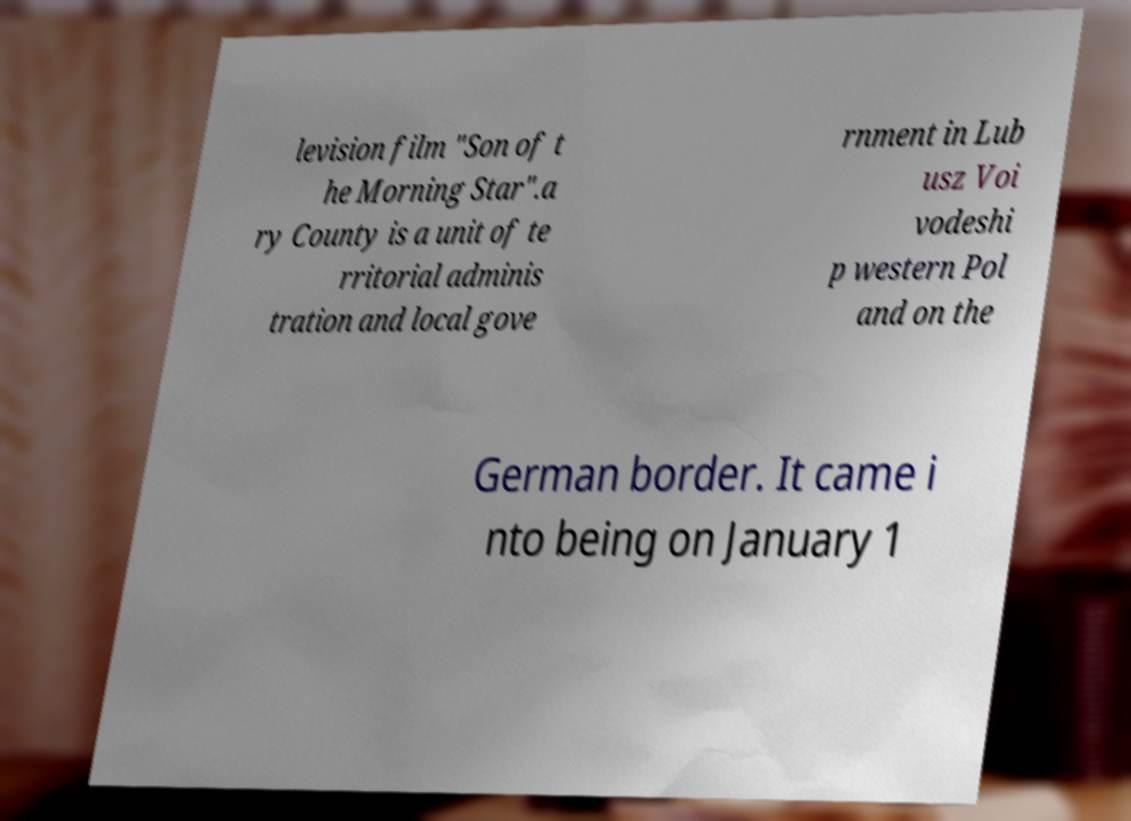Could you extract and type out the text from this image? levision film "Son of t he Morning Star".a ry County is a unit of te rritorial adminis tration and local gove rnment in Lub usz Voi vodeshi p western Pol and on the German border. It came i nto being on January 1 